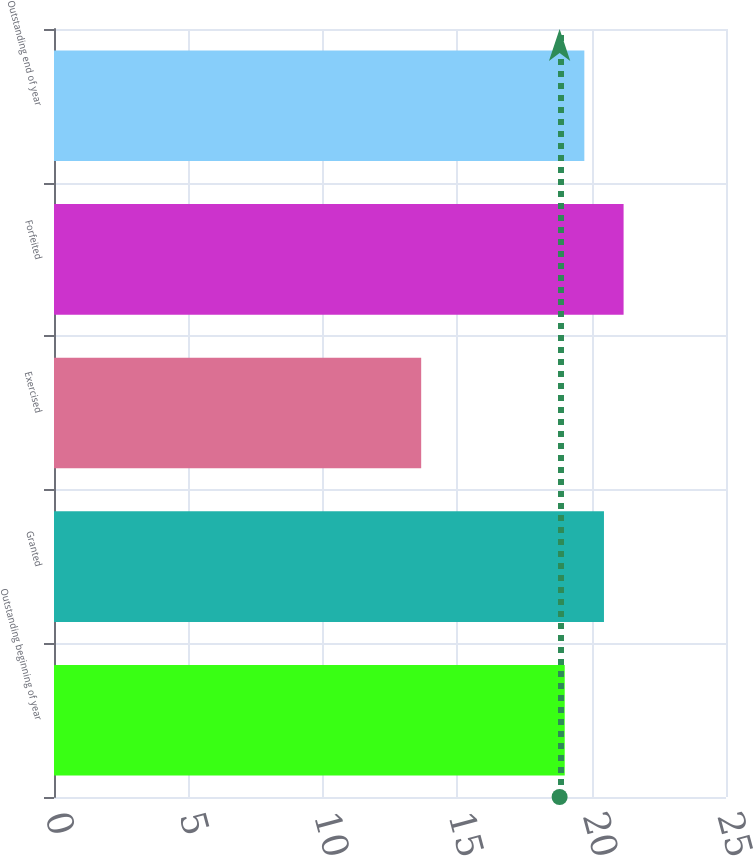Convert chart. <chart><loc_0><loc_0><loc_500><loc_500><bar_chart><fcel>Outstanding beginning of year<fcel>Granted<fcel>Exercised<fcel>Forfeited<fcel>Outstanding end of year<nl><fcel>19<fcel>20.46<fcel>13.66<fcel>21.19<fcel>19.73<nl></chart> 